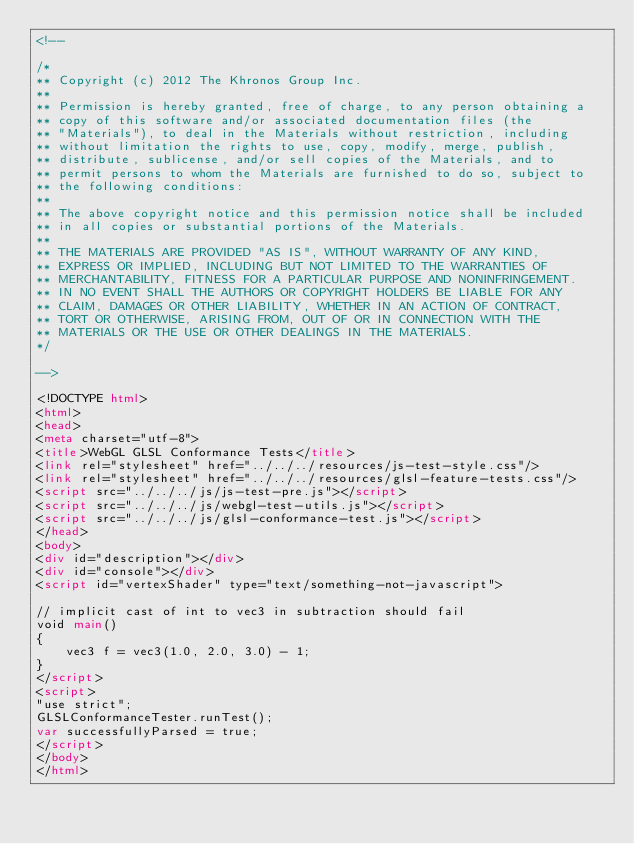<code> <loc_0><loc_0><loc_500><loc_500><_HTML_><!--

/*
** Copyright (c) 2012 The Khronos Group Inc.
**
** Permission is hereby granted, free of charge, to any person obtaining a
** copy of this software and/or associated documentation files (the
** "Materials"), to deal in the Materials without restriction, including
** without limitation the rights to use, copy, modify, merge, publish,
** distribute, sublicense, and/or sell copies of the Materials, and to
** permit persons to whom the Materials are furnished to do so, subject to
** the following conditions:
**
** The above copyright notice and this permission notice shall be included
** in all copies or substantial portions of the Materials.
**
** THE MATERIALS ARE PROVIDED "AS IS", WITHOUT WARRANTY OF ANY KIND,
** EXPRESS OR IMPLIED, INCLUDING BUT NOT LIMITED TO THE WARRANTIES OF
** MERCHANTABILITY, FITNESS FOR A PARTICULAR PURPOSE AND NONINFRINGEMENT.
** IN NO EVENT SHALL THE AUTHORS OR COPYRIGHT HOLDERS BE LIABLE FOR ANY
** CLAIM, DAMAGES OR OTHER LIABILITY, WHETHER IN AN ACTION OF CONTRACT,
** TORT OR OTHERWISE, ARISING FROM, OUT OF OR IN CONNECTION WITH THE
** MATERIALS OR THE USE OR OTHER DEALINGS IN THE MATERIALS.
*/

-->

<!DOCTYPE html>
<html>
<head>
<meta charset="utf-8">
<title>WebGL GLSL Conformance Tests</title>
<link rel="stylesheet" href="../../../resources/js-test-style.css"/>
<link rel="stylesheet" href="../../../resources/glsl-feature-tests.css"/>
<script src="../../../js/js-test-pre.js"></script>
<script src="../../../js/webgl-test-utils.js"></script>
<script src="../../../js/glsl-conformance-test.js"></script>
</head>
<body>
<div id="description"></div>
<div id="console"></div>
<script id="vertexShader" type="text/something-not-javascript">

// implicit cast of int to vec3 in subtraction should fail
void main()
{
    vec3 f = vec3(1.0, 2.0, 3.0) - 1;
}
</script>
<script>
"use strict";
GLSLConformanceTester.runTest();
var successfullyParsed = true;
</script>
</body>
</html>


</code> 